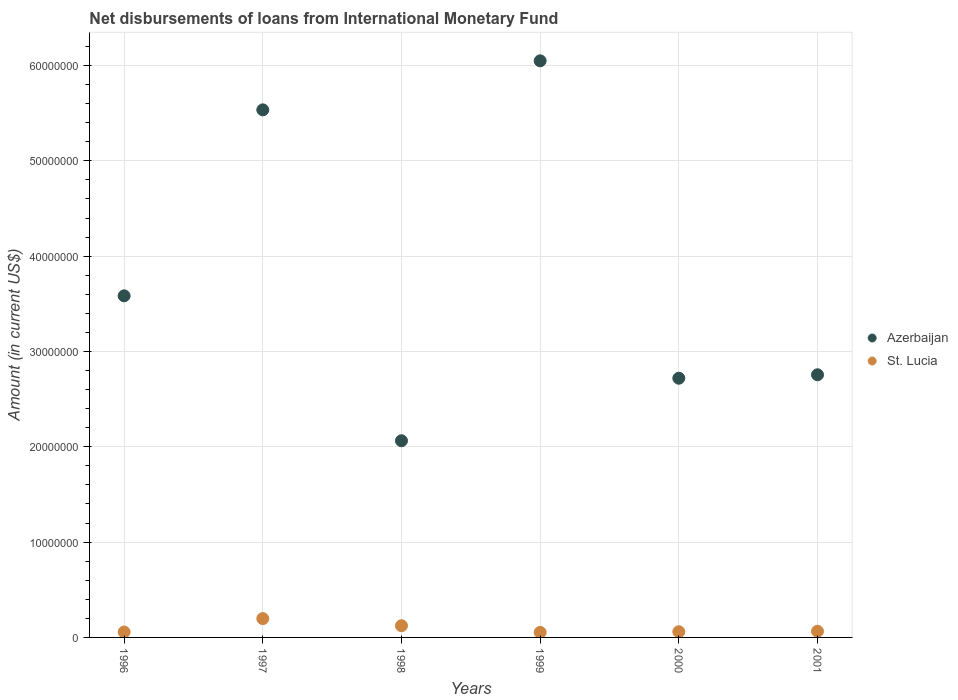How many different coloured dotlines are there?
Offer a terse response. 2. What is the amount of loans disbursed in St. Lucia in 1998?
Your answer should be very brief. 1.23e+06. Across all years, what is the maximum amount of loans disbursed in St. Lucia?
Make the answer very short. 1.98e+06. Across all years, what is the minimum amount of loans disbursed in Azerbaijan?
Make the answer very short. 2.06e+07. In which year was the amount of loans disbursed in St. Lucia minimum?
Make the answer very short. 1999. What is the total amount of loans disbursed in Azerbaijan in the graph?
Offer a very short reply. 2.27e+08. What is the difference between the amount of loans disbursed in St. Lucia in 1998 and that in 2001?
Make the answer very short. 5.83e+05. What is the difference between the amount of loans disbursed in Azerbaijan in 1998 and the amount of loans disbursed in St. Lucia in 1996?
Your response must be concise. 2.01e+07. What is the average amount of loans disbursed in Azerbaijan per year?
Ensure brevity in your answer.  3.78e+07. In the year 1997, what is the difference between the amount of loans disbursed in St. Lucia and amount of loans disbursed in Azerbaijan?
Your answer should be compact. -5.34e+07. In how many years, is the amount of loans disbursed in Azerbaijan greater than 24000000 US$?
Your answer should be compact. 5. What is the ratio of the amount of loans disbursed in St. Lucia in 1997 to that in 2000?
Your response must be concise. 3.3. Is the amount of loans disbursed in Azerbaijan in 1997 less than that in 2000?
Offer a very short reply. No. Is the difference between the amount of loans disbursed in St. Lucia in 1996 and 2000 greater than the difference between the amount of loans disbursed in Azerbaijan in 1996 and 2000?
Keep it short and to the point. No. What is the difference between the highest and the second highest amount of loans disbursed in St. Lucia?
Your answer should be compact. 7.48e+05. What is the difference between the highest and the lowest amount of loans disbursed in St. Lucia?
Your response must be concise. 1.45e+06. Is the sum of the amount of loans disbursed in Azerbaijan in 1998 and 1999 greater than the maximum amount of loans disbursed in St. Lucia across all years?
Offer a very short reply. Yes. Is the amount of loans disbursed in St. Lucia strictly greater than the amount of loans disbursed in Azerbaijan over the years?
Offer a terse response. No. Is the amount of loans disbursed in St. Lucia strictly less than the amount of loans disbursed in Azerbaijan over the years?
Keep it short and to the point. Yes. What is the difference between two consecutive major ticks on the Y-axis?
Your response must be concise. 1.00e+07. Does the graph contain grids?
Offer a very short reply. Yes. Where does the legend appear in the graph?
Your answer should be very brief. Center right. How many legend labels are there?
Ensure brevity in your answer.  2. How are the legend labels stacked?
Keep it short and to the point. Vertical. What is the title of the graph?
Offer a very short reply. Net disbursements of loans from International Monetary Fund. What is the label or title of the Y-axis?
Make the answer very short. Amount (in current US$). What is the Amount (in current US$) of Azerbaijan in 1996?
Provide a succinct answer. 3.58e+07. What is the Amount (in current US$) in St. Lucia in 1996?
Give a very brief answer. 5.67e+05. What is the Amount (in current US$) in Azerbaijan in 1997?
Your answer should be compact. 5.54e+07. What is the Amount (in current US$) in St. Lucia in 1997?
Provide a short and direct response. 1.98e+06. What is the Amount (in current US$) of Azerbaijan in 1998?
Make the answer very short. 2.06e+07. What is the Amount (in current US$) in St. Lucia in 1998?
Offer a terse response. 1.23e+06. What is the Amount (in current US$) in Azerbaijan in 1999?
Offer a terse response. 6.05e+07. What is the Amount (in current US$) in St. Lucia in 1999?
Give a very brief answer. 5.27e+05. What is the Amount (in current US$) of Azerbaijan in 2000?
Provide a succinct answer. 2.72e+07. What is the Amount (in current US$) of St. Lucia in 2000?
Offer a terse response. 5.98e+05. What is the Amount (in current US$) in Azerbaijan in 2001?
Your answer should be compact. 2.76e+07. What is the Amount (in current US$) of St. Lucia in 2001?
Provide a succinct answer. 6.45e+05. Across all years, what is the maximum Amount (in current US$) in Azerbaijan?
Ensure brevity in your answer.  6.05e+07. Across all years, what is the maximum Amount (in current US$) of St. Lucia?
Your answer should be very brief. 1.98e+06. Across all years, what is the minimum Amount (in current US$) of Azerbaijan?
Your response must be concise. 2.06e+07. Across all years, what is the minimum Amount (in current US$) of St. Lucia?
Make the answer very short. 5.27e+05. What is the total Amount (in current US$) of Azerbaijan in the graph?
Provide a short and direct response. 2.27e+08. What is the total Amount (in current US$) in St. Lucia in the graph?
Make the answer very short. 5.54e+06. What is the difference between the Amount (in current US$) in Azerbaijan in 1996 and that in 1997?
Your answer should be very brief. -1.95e+07. What is the difference between the Amount (in current US$) of St. Lucia in 1996 and that in 1997?
Your answer should be compact. -1.41e+06. What is the difference between the Amount (in current US$) in Azerbaijan in 1996 and that in 1998?
Your answer should be very brief. 1.52e+07. What is the difference between the Amount (in current US$) in St. Lucia in 1996 and that in 1998?
Offer a very short reply. -6.61e+05. What is the difference between the Amount (in current US$) of Azerbaijan in 1996 and that in 1999?
Ensure brevity in your answer.  -2.47e+07. What is the difference between the Amount (in current US$) of Azerbaijan in 1996 and that in 2000?
Your response must be concise. 8.64e+06. What is the difference between the Amount (in current US$) in St. Lucia in 1996 and that in 2000?
Ensure brevity in your answer.  -3.10e+04. What is the difference between the Amount (in current US$) in Azerbaijan in 1996 and that in 2001?
Keep it short and to the point. 8.28e+06. What is the difference between the Amount (in current US$) in St. Lucia in 1996 and that in 2001?
Provide a succinct answer. -7.80e+04. What is the difference between the Amount (in current US$) in Azerbaijan in 1997 and that in 1998?
Your response must be concise. 3.47e+07. What is the difference between the Amount (in current US$) in St. Lucia in 1997 and that in 1998?
Offer a terse response. 7.48e+05. What is the difference between the Amount (in current US$) of Azerbaijan in 1997 and that in 1999?
Your response must be concise. -5.14e+06. What is the difference between the Amount (in current US$) in St. Lucia in 1997 and that in 1999?
Give a very brief answer. 1.45e+06. What is the difference between the Amount (in current US$) of Azerbaijan in 1997 and that in 2000?
Give a very brief answer. 2.82e+07. What is the difference between the Amount (in current US$) of St. Lucia in 1997 and that in 2000?
Provide a succinct answer. 1.38e+06. What is the difference between the Amount (in current US$) of Azerbaijan in 1997 and that in 2001?
Give a very brief answer. 2.78e+07. What is the difference between the Amount (in current US$) in St. Lucia in 1997 and that in 2001?
Your answer should be very brief. 1.33e+06. What is the difference between the Amount (in current US$) in Azerbaijan in 1998 and that in 1999?
Keep it short and to the point. -3.99e+07. What is the difference between the Amount (in current US$) of St. Lucia in 1998 and that in 1999?
Your answer should be very brief. 7.01e+05. What is the difference between the Amount (in current US$) in Azerbaijan in 1998 and that in 2000?
Make the answer very short. -6.56e+06. What is the difference between the Amount (in current US$) in St. Lucia in 1998 and that in 2000?
Ensure brevity in your answer.  6.30e+05. What is the difference between the Amount (in current US$) in Azerbaijan in 1998 and that in 2001?
Offer a terse response. -6.92e+06. What is the difference between the Amount (in current US$) in St. Lucia in 1998 and that in 2001?
Ensure brevity in your answer.  5.83e+05. What is the difference between the Amount (in current US$) in Azerbaijan in 1999 and that in 2000?
Your answer should be compact. 3.33e+07. What is the difference between the Amount (in current US$) of St. Lucia in 1999 and that in 2000?
Provide a succinct answer. -7.10e+04. What is the difference between the Amount (in current US$) of Azerbaijan in 1999 and that in 2001?
Offer a terse response. 3.29e+07. What is the difference between the Amount (in current US$) of St. Lucia in 1999 and that in 2001?
Your answer should be very brief. -1.18e+05. What is the difference between the Amount (in current US$) of Azerbaijan in 2000 and that in 2001?
Provide a short and direct response. -3.61e+05. What is the difference between the Amount (in current US$) in St. Lucia in 2000 and that in 2001?
Provide a short and direct response. -4.70e+04. What is the difference between the Amount (in current US$) in Azerbaijan in 1996 and the Amount (in current US$) in St. Lucia in 1997?
Your answer should be very brief. 3.39e+07. What is the difference between the Amount (in current US$) of Azerbaijan in 1996 and the Amount (in current US$) of St. Lucia in 1998?
Offer a very short reply. 3.46e+07. What is the difference between the Amount (in current US$) in Azerbaijan in 1996 and the Amount (in current US$) in St. Lucia in 1999?
Provide a succinct answer. 3.53e+07. What is the difference between the Amount (in current US$) in Azerbaijan in 1996 and the Amount (in current US$) in St. Lucia in 2000?
Keep it short and to the point. 3.52e+07. What is the difference between the Amount (in current US$) in Azerbaijan in 1996 and the Amount (in current US$) in St. Lucia in 2001?
Keep it short and to the point. 3.52e+07. What is the difference between the Amount (in current US$) of Azerbaijan in 1997 and the Amount (in current US$) of St. Lucia in 1998?
Offer a very short reply. 5.41e+07. What is the difference between the Amount (in current US$) in Azerbaijan in 1997 and the Amount (in current US$) in St. Lucia in 1999?
Give a very brief answer. 5.48e+07. What is the difference between the Amount (in current US$) of Azerbaijan in 1997 and the Amount (in current US$) of St. Lucia in 2000?
Give a very brief answer. 5.48e+07. What is the difference between the Amount (in current US$) in Azerbaijan in 1997 and the Amount (in current US$) in St. Lucia in 2001?
Your answer should be compact. 5.47e+07. What is the difference between the Amount (in current US$) of Azerbaijan in 1998 and the Amount (in current US$) of St. Lucia in 1999?
Give a very brief answer. 2.01e+07. What is the difference between the Amount (in current US$) in Azerbaijan in 1998 and the Amount (in current US$) in St. Lucia in 2000?
Make the answer very short. 2.00e+07. What is the difference between the Amount (in current US$) of Azerbaijan in 1998 and the Amount (in current US$) of St. Lucia in 2001?
Ensure brevity in your answer.  2.00e+07. What is the difference between the Amount (in current US$) of Azerbaijan in 1999 and the Amount (in current US$) of St. Lucia in 2000?
Your answer should be compact. 5.99e+07. What is the difference between the Amount (in current US$) in Azerbaijan in 1999 and the Amount (in current US$) in St. Lucia in 2001?
Give a very brief answer. 5.99e+07. What is the difference between the Amount (in current US$) in Azerbaijan in 2000 and the Amount (in current US$) in St. Lucia in 2001?
Offer a very short reply. 2.66e+07. What is the average Amount (in current US$) of Azerbaijan per year?
Offer a terse response. 3.78e+07. What is the average Amount (in current US$) of St. Lucia per year?
Offer a very short reply. 9.24e+05. In the year 1996, what is the difference between the Amount (in current US$) of Azerbaijan and Amount (in current US$) of St. Lucia?
Make the answer very short. 3.53e+07. In the year 1997, what is the difference between the Amount (in current US$) of Azerbaijan and Amount (in current US$) of St. Lucia?
Make the answer very short. 5.34e+07. In the year 1998, what is the difference between the Amount (in current US$) in Azerbaijan and Amount (in current US$) in St. Lucia?
Give a very brief answer. 1.94e+07. In the year 1999, what is the difference between the Amount (in current US$) of Azerbaijan and Amount (in current US$) of St. Lucia?
Offer a terse response. 6.00e+07. In the year 2000, what is the difference between the Amount (in current US$) of Azerbaijan and Amount (in current US$) of St. Lucia?
Give a very brief answer. 2.66e+07. In the year 2001, what is the difference between the Amount (in current US$) of Azerbaijan and Amount (in current US$) of St. Lucia?
Your answer should be compact. 2.69e+07. What is the ratio of the Amount (in current US$) in Azerbaijan in 1996 to that in 1997?
Ensure brevity in your answer.  0.65. What is the ratio of the Amount (in current US$) in St. Lucia in 1996 to that in 1997?
Keep it short and to the point. 0.29. What is the ratio of the Amount (in current US$) in Azerbaijan in 1996 to that in 1998?
Make the answer very short. 1.74. What is the ratio of the Amount (in current US$) in St. Lucia in 1996 to that in 1998?
Offer a terse response. 0.46. What is the ratio of the Amount (in current US$) in Azerbaijan in 1996 to that in 1999?
Provide a short and direct response. 0.59. What is the ratio of the Amount (in current US$) in St. Lucia in 1996 to that in 1999?
Keep it short and to the point. 1.08. What is the ratio of the Amount (in current US$) in Azerbaijan in 1996 to that in 2000?
Your answer should be compact. 1.32. What is the ratio of the Amount (in current US$) of St. Lucia in 1996 to that in 2000?
Make the answer very short. 0.95. What is the ratio of the Amount (in current US$) of Azerbaijan in 1996 to that in 2001?
Give a very brief answer. 1.3. What is the ratio of the Amount (in current US$) in St. Lucia in 1996 to that in 2001?
Provide a succinct answer. 0.88. What is the ratio of the Amount (in current US$) of Azerbaijan in 1997 to that in 1998?
Give a very brief answer. 2.68. What is the ratio of the Amount (in current US$) of St. Lucia in 1997 to that in 1998?
Your response must be concise. 1.61. What is the ratio of the Amount (in current US$) in Azerbaijan in 1997 to that in 1999?
Offer a very short reply. 0.92. What is the ratio of the Amount (in current US$) in St. Lucia in 1997 to that in 1999?
Give a very brief answer. 3.75. What is the ratio of the Amount (in current US$) of Azerbaijan in 1997 to that in 2000?
Your response must be concise. 2.04. What is the ratio of the Amount (in current US$) of St. Lucia in 1997 to that in 2000?
Provide a short and direct response. 3.3. What is the ratio of the Amount (in current US$) of Azerbaijan in 1997 to that in 2001?
Provide a succinct answer. 2.01. What is the ratio of the Amount (in current US$) of St. Lucia in 1997 to that in 2001?
Provide a short and direct response. 3.06. What is the ratio of the Amount (in current US$) in Azerbaijan in 1998 to that in 1999?
Your response must be concise. 0.34. What is the ratio of the Amount (in current US$) of St. Lucia in 1998 to that in 1999?
Provide a short and direct response. 2.33. What is the ratio of the Amount (in current US$) of Azerbaijan in 1998 to that in 2000?
Ensure brevity in your answer.  0.76. What is the ratio of the Amount (in current US$) of St. Lucia in 1998 to that in 2000?
Provide a succinct answer. 2.05. What is the ratio of the Amount (in current US$) in Azerbaijan in 1998 to that in 2001?
Your answer should be very brief. 0.75. What is the ratio of the Amount (in current US$) in St. Lucia in 1998 to that in 2001?
Offer a terse response. 1.9. What is the ratio of the Amount (in current US$) in Azerbaijan in 1999 to that in 2000?
Ensure brevity in your answer.  2.22. What is the ratio of the Amount (in current US$) of St. Lucia in 1999 to that in 2000?
Keep it short and to the point. 0.88. What is the ratio of the Amount (in current US$) of Azerbaijan in 1999 to that in 2001?
Make the answer very short. 2.2. What is the ratio of the Amount (in current US$) of St. Lucia in 1999 to that in 2001?
Provide a short and direct response. 0.82. What is the ratio of the Amount (in current US$) in Azerbaijan in 2000 to that in 2001?
Offer a terse response. 0.99. What is the ratio of the Amount (in current US$) of St. Lucia in 2000 to that in 2001?
Keep it short and to the point. 0.93. What is the difference between the highest and the second highest Amount (in current US$) in Azerbaijan?
Your answer should be very brief. 5.14e+06. What is the difference between the highest and the second highest Amount (in current US$) in St. Lucia?
Your answer should be compact. 7.48e+05. What is the difference between the highest and the lowest Amount (in current US$) of Azerbaijan?
Your answer should be very brief. 3.99e+07. What is the difference between the highest and the lowest Amount (in current US$) of St. Lucia?
Give a very brief answer. 1.45e+06. 